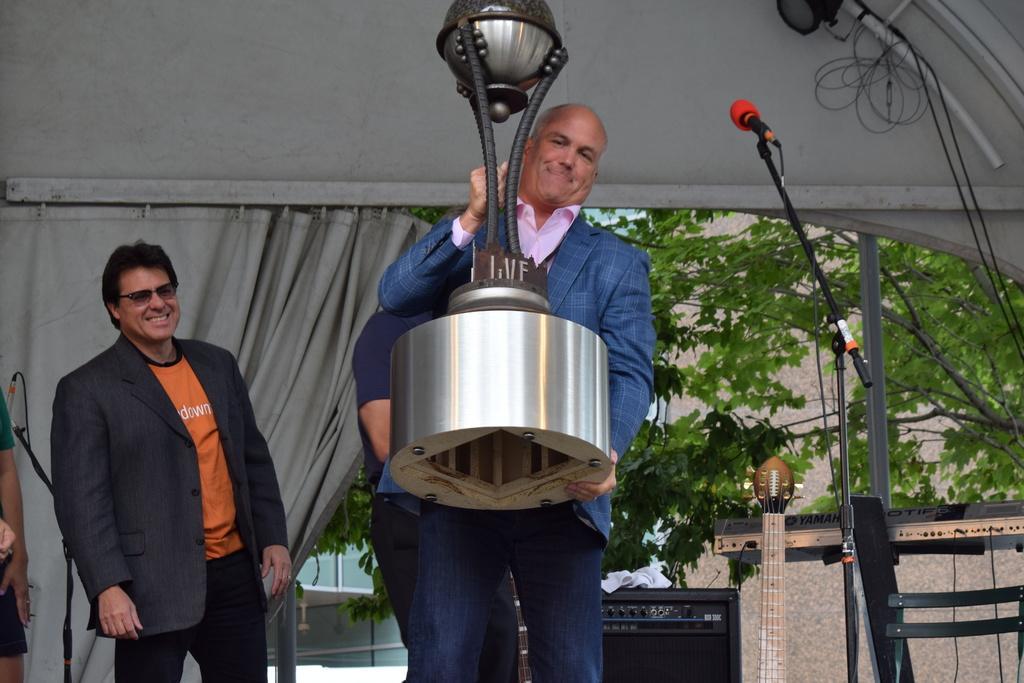Can you describe this image briefly? This image is taken outdoors. In the background there are a few trees and there is a building. There is a curtain. At the top of the image there is a wall. On the left side of the image two men are standing and there is a mic. In the middle of the image two men are standing and a man is holding a big trophy in his hands. On the right side of the image there is a mic and there is an object. There is a chair and a guitar. 